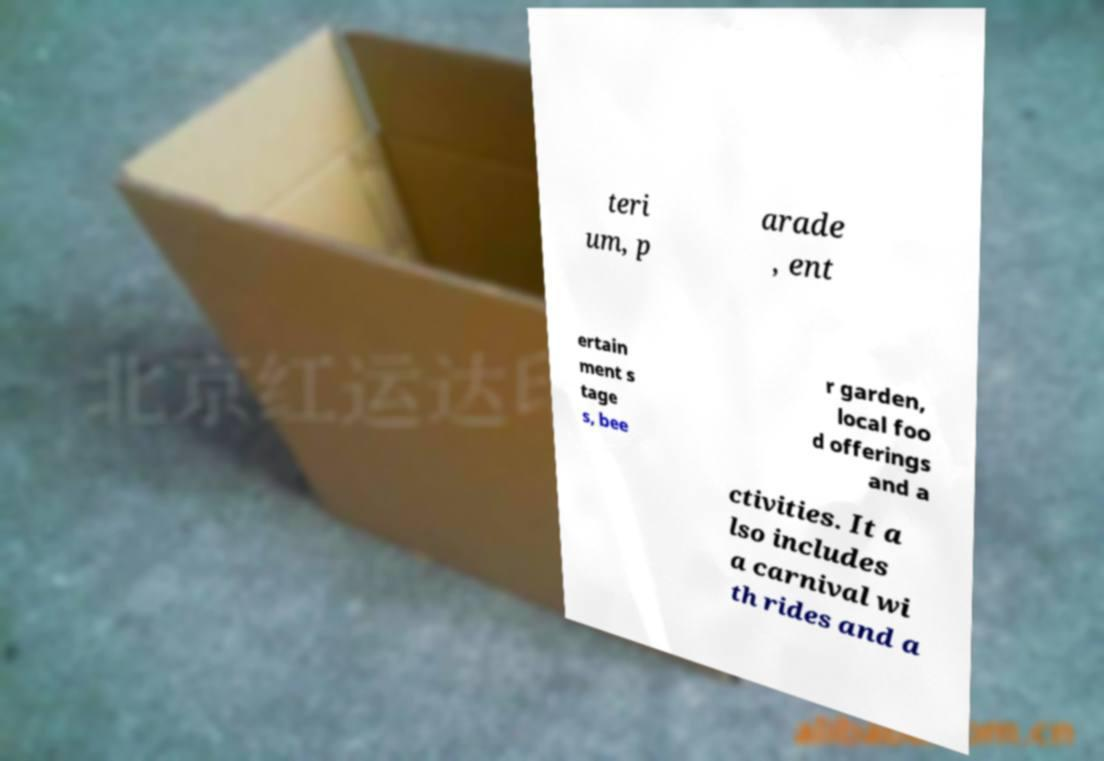There's text embedded in this image that I need extracted. Can you transcribe it verbatim? teri um, p arade , ent ertain ment s tage s, bee r garden, local foo d offerings and a ctivities. It a lso includes a carnival wi th rides and a 